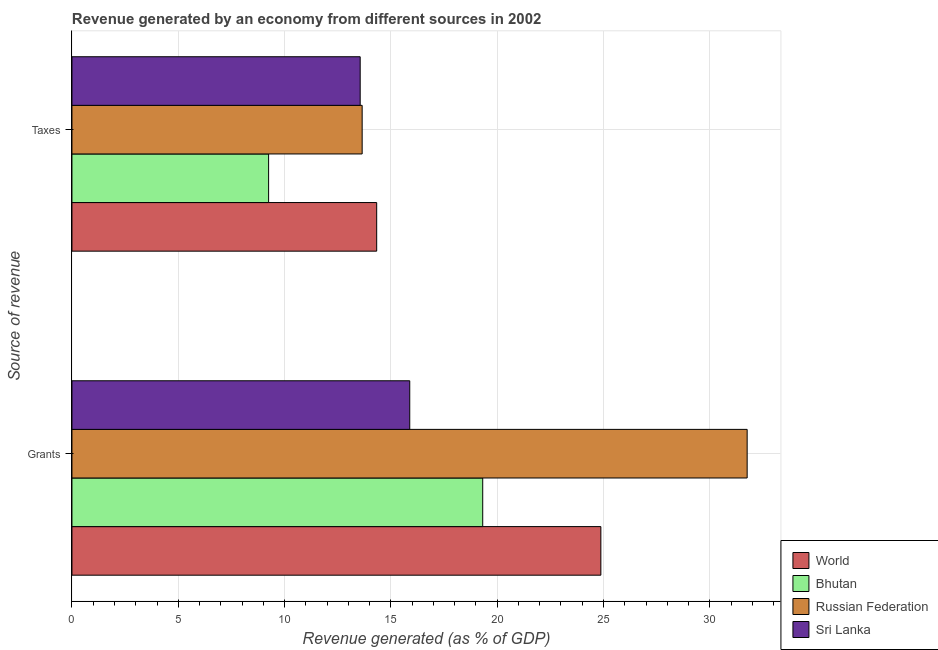Are the number of bars per tick equal to the number of legend labels?
Provide a succinct answer. Yes. How many bars are there on the 2nd tick from the bottom?
Keep it short and to the point. 4. What is the label of the 2nd group of bars from the top?
Give a very brief answer. Grants. What is the revenue generated by taxes in Sri Lanka?
Give a very brief answer. 13.56. Across all countries, what is the maximum revenue generated by grants?
Provide a succinct answer. 31.76. Across all countries, what is the minimum revenue generated by taxes?
Ensure brevity in your answer.  9.25. In which country was the revenue generated by grants maximum?
Give a very brief answer. Russian Federation. In which country was the revenue generated by grants minimum?
Give a very brief answer. Sri Lanka. What is the total revenue generated by taxes in the graph?
Ensure brevity in your answer.  50.79. What is the difference between the revenue generated by taxes in Bhutan and that in Sri Lanka?
Offer a very short reply. -4.31. What is the difference between the revenue generated by taxes in World and the revenue generated by grants in Sri Lanka?
Ensure brevity in your answer.  -1.55. What is the average revenue generated by taxes per country?
Your answer should be very brief. 12.7. What is the difference between the revenue generated by taxes and revenue generated by grants in Bhutan?
Give a very brief answer. -10.07. In how many countries, is the revenue generated by taxes greater than 3 %?
Keep it short and to the point. 4. What is the ratio of the revenue generated by taxes in Russian Federation to that in Bhutan?
Your answer should be compact. 1.48. Is the revenue generated by taxes in World less than that in Russian Federation?
Make the answer very short. No. In how many countries, is the revenue generated by taxes greater than the average revenue generated by taxes taken over all countries?
Make the answer very short. 3. What does the 1st bar from the top in Taxes represents?
Offer a very short reply. Sri Lanka. What does the 1st bar from the bottom in Grants represents?
Provide a short and direct response. World. How many countries are there in the graph?
Offer a very short reply. 4. Are the values on the major ticks of X-axis written in scientific E-notation?
Offer a terse response. No. Does the graph contain grids?
Make the answer very short. Yes. What is the title of the graph?
Keep it short and to the point. Revenue generated by an economy from different sources in 2002. What is the label or title of the X-axis?
Your answer should be very brief. Revenue generated (as % of GDP). What is the label or title of the Y-axis?
Make the answer very short. Source of revenue. What is the Revenue generated (as % of GDP) in World in Grants?
Give a very brief answer. 24.88. What is the Revenue generated (as % of GDP) in Bhutan in Grants?
Provide a short and direct response. 19.32. What is the Revenue generated (as % of GDP) in Russian Federation in Grants?
Provide a succinct answer. 31.76. What is the Revenue generated (as % of GDP) in Sri Lanka in Grants?
Keep it short and to the point. 15.89. What is the Revenue generated (as % of GDP) in World in Taxes?
Offer a terse response. 14.33. What is the Revenue generated (as % of GDP) in Bhutan in Taxes?
Ensure brevity in your answer.  9.25. What is the Revenue generated (as % of GDP) in Russian Federation in Taxes?
Provide a short and direct response. 13.65. What is the Revenue generated (as % of GDP) of Sri Lanka in Taxes?
Provide a succinct answer. 13.56. Across all Source of revenue, what is the maximum Revenue generated (as % of GDP) in World?
Ensure brevity in your answer.  24.88. Across all Source of revenue, what is the maximum Revenue generated (as % of GDP) in Bhutan?
Offer a terse response. 19.32. Across all Source of revenue, what is the maximum Revenue generated (as % of GDP) of Russian Federation?
Make the answer very short. 31.76. Across all Source of revenue, what is the maximum Revenue generated (as % of GDP) in Sri Lanka?
Your response must be concise. 15.89. Across all Source of revenue, what is the minimum Revenue generated (as % of GDP) in World?
Your answer should be compact. 14.33. Across all Source of revenue, what is the minimum Revenue generated (as % of GDP) in Bhutan?
Your response must be concise. 9.25. Across all Source of revenue, what is the minimum Revenue generated (as % of GDP) of Russian Federation?
Your response must be concise. 13.65. Across all Source of revenue, what is the minimum Revenue generated (as % of GDP) in Sri Lanka?
Ensure brevity in your answer.  13.56. What is the total Revenue generated (as % of GDP) of World in the graph?
Provide a short and direct response. 39.21. What is the total Revenue generated (as % of GDP) in Bhutan in the graph?
Provide a succinct answer. 28.57. What is the total Revenue generated (as % of GDP) in Russian Federation in the graph?
Your answer should be very brief. 45.41. What is the total Revenue generated (as % of GDP) in Sri Lanka in the graph?
Your answer should be very brief. 29.44. What is the difference between the Revenue generated (as % of GDP) in World in Grants and that in Taxes?
Your response must be concise. 10.54. What is the difference between the Revenue generated (as % of GDP) in Bhutan in Grants and that in Taxes?
Provide a succinct answer. 10.07. What is the difference between the Revenue generated (as % of GDP) in Russian Federation in Grants and that in Taxes?
Make the answer very short. 18.11. What is the difference between the Revenue generated (as % of GDP) of Sri Lanka in Grants and that in Taxes?
Make the answer very short. 2.33. What is the difference between the Revenue generated (as % of GDP) in World in Grants and the Revenue generated (as % of GDP) in Bhutan in Taxes?
Keep it short and to the point. 15.63. What is the difference between the Revenue generated (as % of GDP) in World in Grants and the Revenue generated (as % of GDP) in Russian Federation in Taxes?
Keep it short and to the point. 11.23. What is the difference between the Revenue generated (as % of GDP) of World in Grants and the Revenue generated (as % of GDP) of Sri Lanka in Taxes?
Your response must be concise. 11.32. What is the difference between the Revenue generated (as % of GDP) in Bhutan in Grants and the Revenue generated (as % of GDP) in Russian Federation in Taxes?
Your answer should be compact. 5.67. What is the difference between the Revenue generated (as % of GDP) of Bhutan in Grants and the Revenue generated (as % of GDP) of Sri Lanka in Taxes?
Offer a very short reply. 5.76. What is the average Revenue generated (as % of GDP) in World per Source of revenue?
Ensure brevity in your answer.  19.6. What is the average Revenue generated (as % of GDP) in Bhutan per Source of revenue?
Provide a succinct answer. 14.28. What is the average Revenue generated (as % of GDP) in Russian Federation per Source of revenue?
Offer a terse response. 22.7. What is the average Revenue generated (as % of GDP) of Sri Lanka per Source of revenue?
Give a very brief answer. 14.72. What is the difference between the Revenue generated (as % of GDP) of World and Revenue generated (as % of GDP) of Bhutan in Grants?
Your response must be concise. 5.56. What is the difference between the Revenue generated (as % of GDP) of World and Revenue generated (as % of GDP) of Russian Federation in Grants?
Offer a terse response. -6.88. What is the difference between the Revenue generated (as % of GDP) of World and Revenue generated (as % of GDP) of Sri Lanka in Grants?
Make the answer very short. 8.99. What is the difference between the Revenue generated (as % of GDP) of Bhutan and Revenue generated (as % of GDP) of Russian Federation in Grants?
Offer a terse response. -12.44. What is the difference between the Revenue generated (as % of GDP) in Bhutan and Revenue generated (as % of GDP) in Sri Lanka in Grants?
Offer a terse response. 3.43. What is the difference between the Revenue generated (as % of GDP) in Russian Federation and Revenue generated (as % of GDP) in Sri Lanka in Grants?
Make the answer very short. 15.87. What is the difference between the Revenue generated (as % of GDP) in World and Revenue generated (as % of GDP) in Bhutan in Taxes?
Give a very brief answer. 5.08. What is the difference between the Revenue generated (as % of GDP) in World and Revenue generated (as % of GDP) in Russian Federation in Taxes?
Your answer should be very brief. 0.68. What is the difference between the Revenue generated (as % of GDP) of World and Revenue generated (as % of GDP) of Sri Lanka in Taxes?
Your answer should be compact. 0.78. What is the difference between the Revenue generated (as % of GDP) in Bhutan and Revenue generated (as % of GDP) in Russian Federation in Taxes?
Your answer should be compact. -4.4. What is the difference between the Revenue generated (as % of GDP) in Bhutan and Revenue generated (as % of GDP) in Sri Lanka in Taxes?
Offer a terse response. -4.31. What is the difference between the Revenue generated (as % of GDP) in Russian Federation and Revenue generated (as % of GDP) in Sri Lanka in Taxes?
Provide a succinct answer. 0.09. What is the ratio of the Revenue generated (as % of GDP) of World in Grants to that in Taxes?
Your answer should be very brief. 1.74. What is the ratio of the Revenue generated (as % of GDP) of Bhutan in Grants to that in Taxes?
Provide a succinct answer. 2.09. What is the ratio of the Revenue generated (as % of GDP) in Russian Federation in Grants to that in Taxes?
Provide a succinct answer. 2.33. What is the ratio of the Revenue generated (as % of GDP) in Sri Lanka in Grants to that in Taxes?
Give a very brief answer. 1.17. What is the difference between the highest and the second highest Revenue generated (as % of GDP) in World?
Provide a short and direct response. 10.54. What is the difference between the highest and the second highest Revenue generated (as % of GDP) in Bhutan?
Your response must be concise. 10.07. What is the difference between the highest and the second highest Revenue generated (as % of GDP) in Russian Federation?
Make the answer very short. 18.11. What is the difference between the highest and the second highest Revenue generated (as % of GDP) of Sri Lanka?
Ensure brevity in your answer.  2.33. What is the difference between the highest and the lowest Revenue generated (as % of GDP) of World?
Offer a terse response. 10.54. What is the difference between the highest and the lowest Revenue generated (as % of GDP) in Bhutan?
Give a very brief answer. 10.07. What is the difference between the highest and the lowest Revenue generated (as % of GDP) in Russian Federation?
Give a very brief answer. 18.11. What is the difference between the highest and the lowest Revenue generated (as % of GDP) of Sri Lanka?
Offer a very short reply. 2.33. 